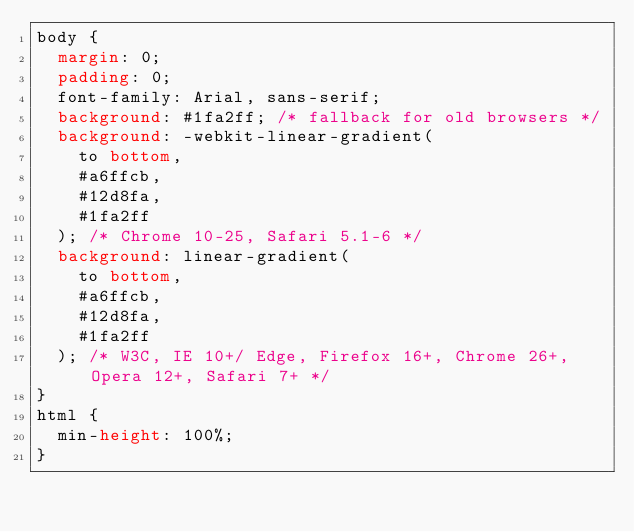Convert code to text. <code><loc_0><loc_0><loc_500><loc_500><_CSS_>body {
  margin: 0;
  padding: 0;
  font-family: Arial, sans-serif;
  background: #1fa2ff; /* fallback for old browsers */
  background: -webkit-linear-gradient(
    to bottom,
    #a6ffcb,
    #12d8fa,
    #1fa2ff
  ); /* Chrome 10-25, Safari 5.1-6 */
  background: linear-gradient(
    to bottom,
    #a6ffcb,
    #12d8fa,
    #1fa2ff
  ); /* W3C, IE 10+/ Edge, Firefox 16+, Chrome 26+, Opera 12+, Safari 7+ */
}
html {
  min-height: 100%;
}
</code> 